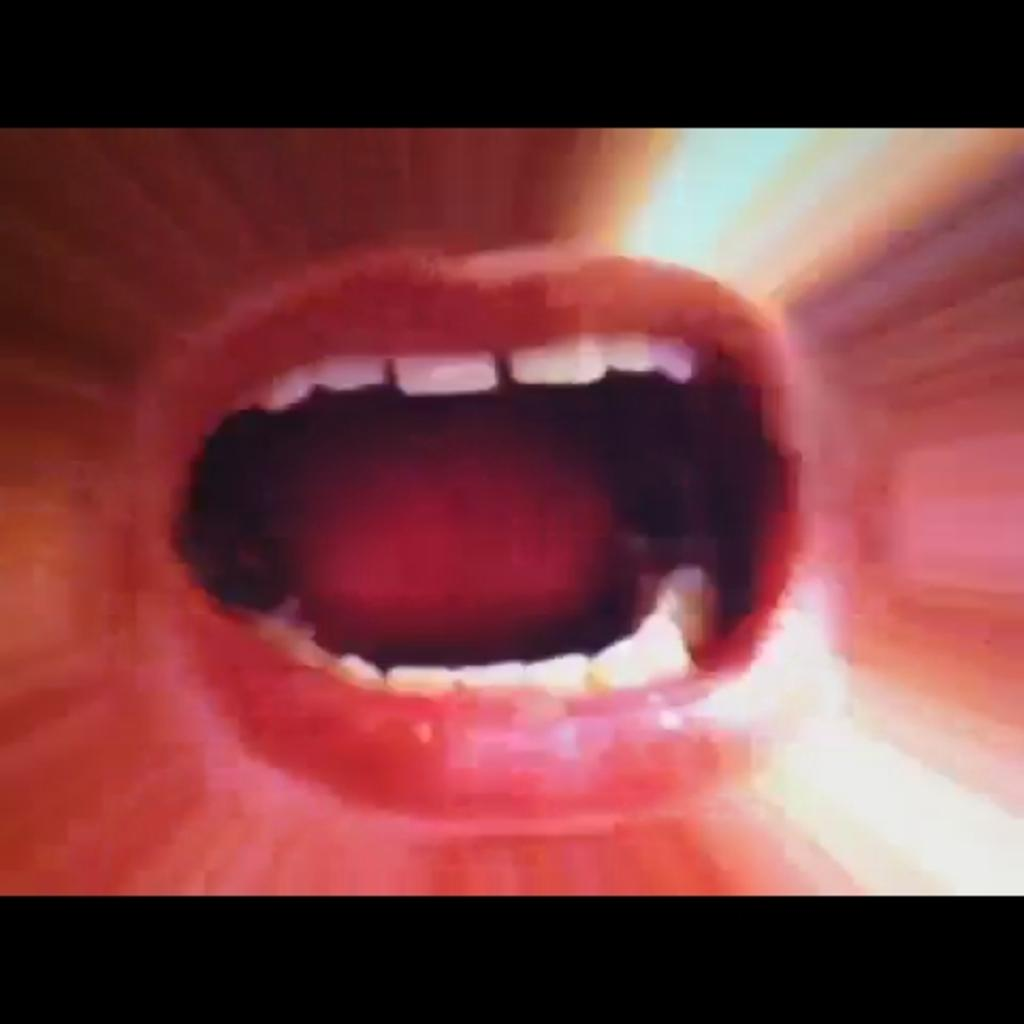What is the main feature of the image? There is a mouth in the image. What can be seen inside the mouth? Teeth are visible in the image. What time is displayed on the clock in the image? There is no clock present in the image; it only features a mouth and teeth. What type of hose can be seen connected to the channel in the image? There is no hose or channel present in the image; it only features a mouth and teeth. 